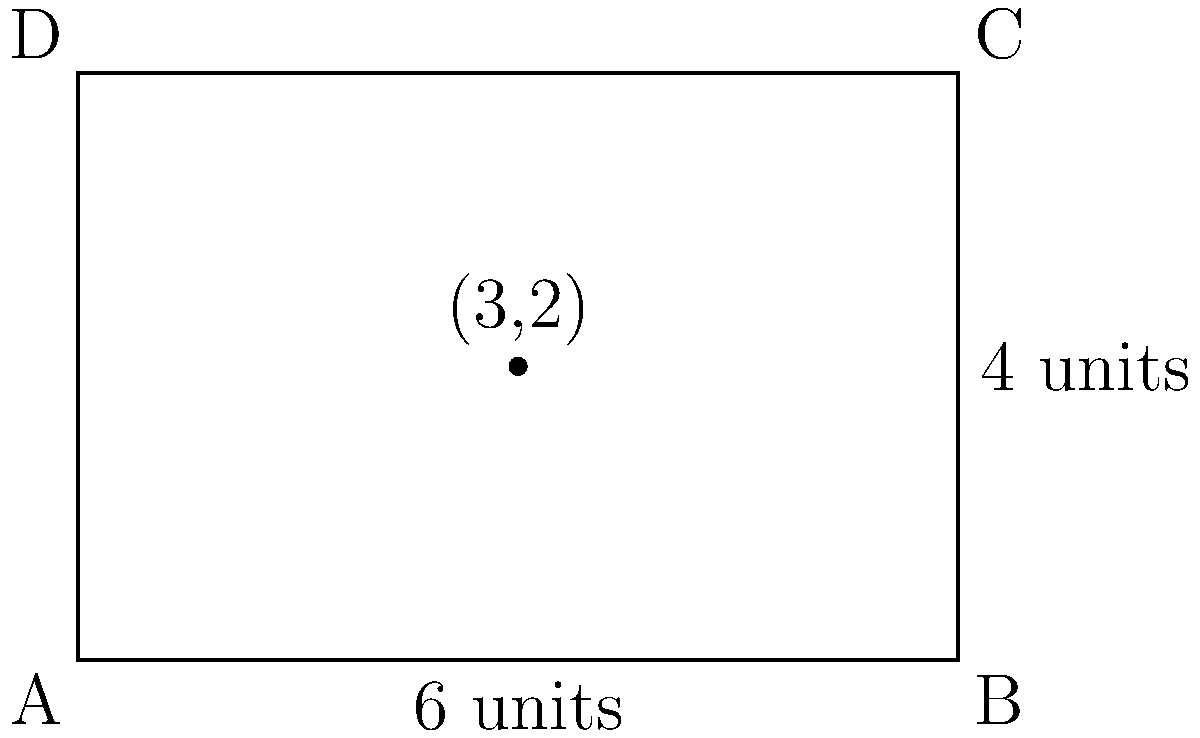A conservative news publication's market share can be represented by a rectangular region in the xy-plane. The region is bounded by the x-axis, y-axis, the line $x=6$, and the line $y=4$. If the point $(3,2)$ represents the publication's current market position, calculate the area of the region to determine the total potential market share. How does this compare to the liberal media's often exaggerated claims about climate change impact? To calculate the area of the rectangular region representing the conservative news publication's market share, we'll follow these steps:

1) The rectangular region is defined by two key dimensions:
   - Width: from $x=0$ to $x=6$, so the width is 6 units
   - Height: from $y=0$ to $y=4$, so the height is 4 units

2) The area of a rectangle is given by the formula:
   $$ A = w \times h $$
   where $A$ is the area, $w$ is the width, and $h$ is the height.

3) Substituting our values:
   $$ A = 6 \times 4 = 24 $$

4) Therefore, the area of the rectangular region is 24 square units.

This representation of market share as a concrete, measurable area contrasts with the often abstract and potentially exaggerated claims about climate change impact. Just as we can precisely calculate this area, we should demand equally precise and verifiable data from those making claims about climate change.
Answer: 24 square units 